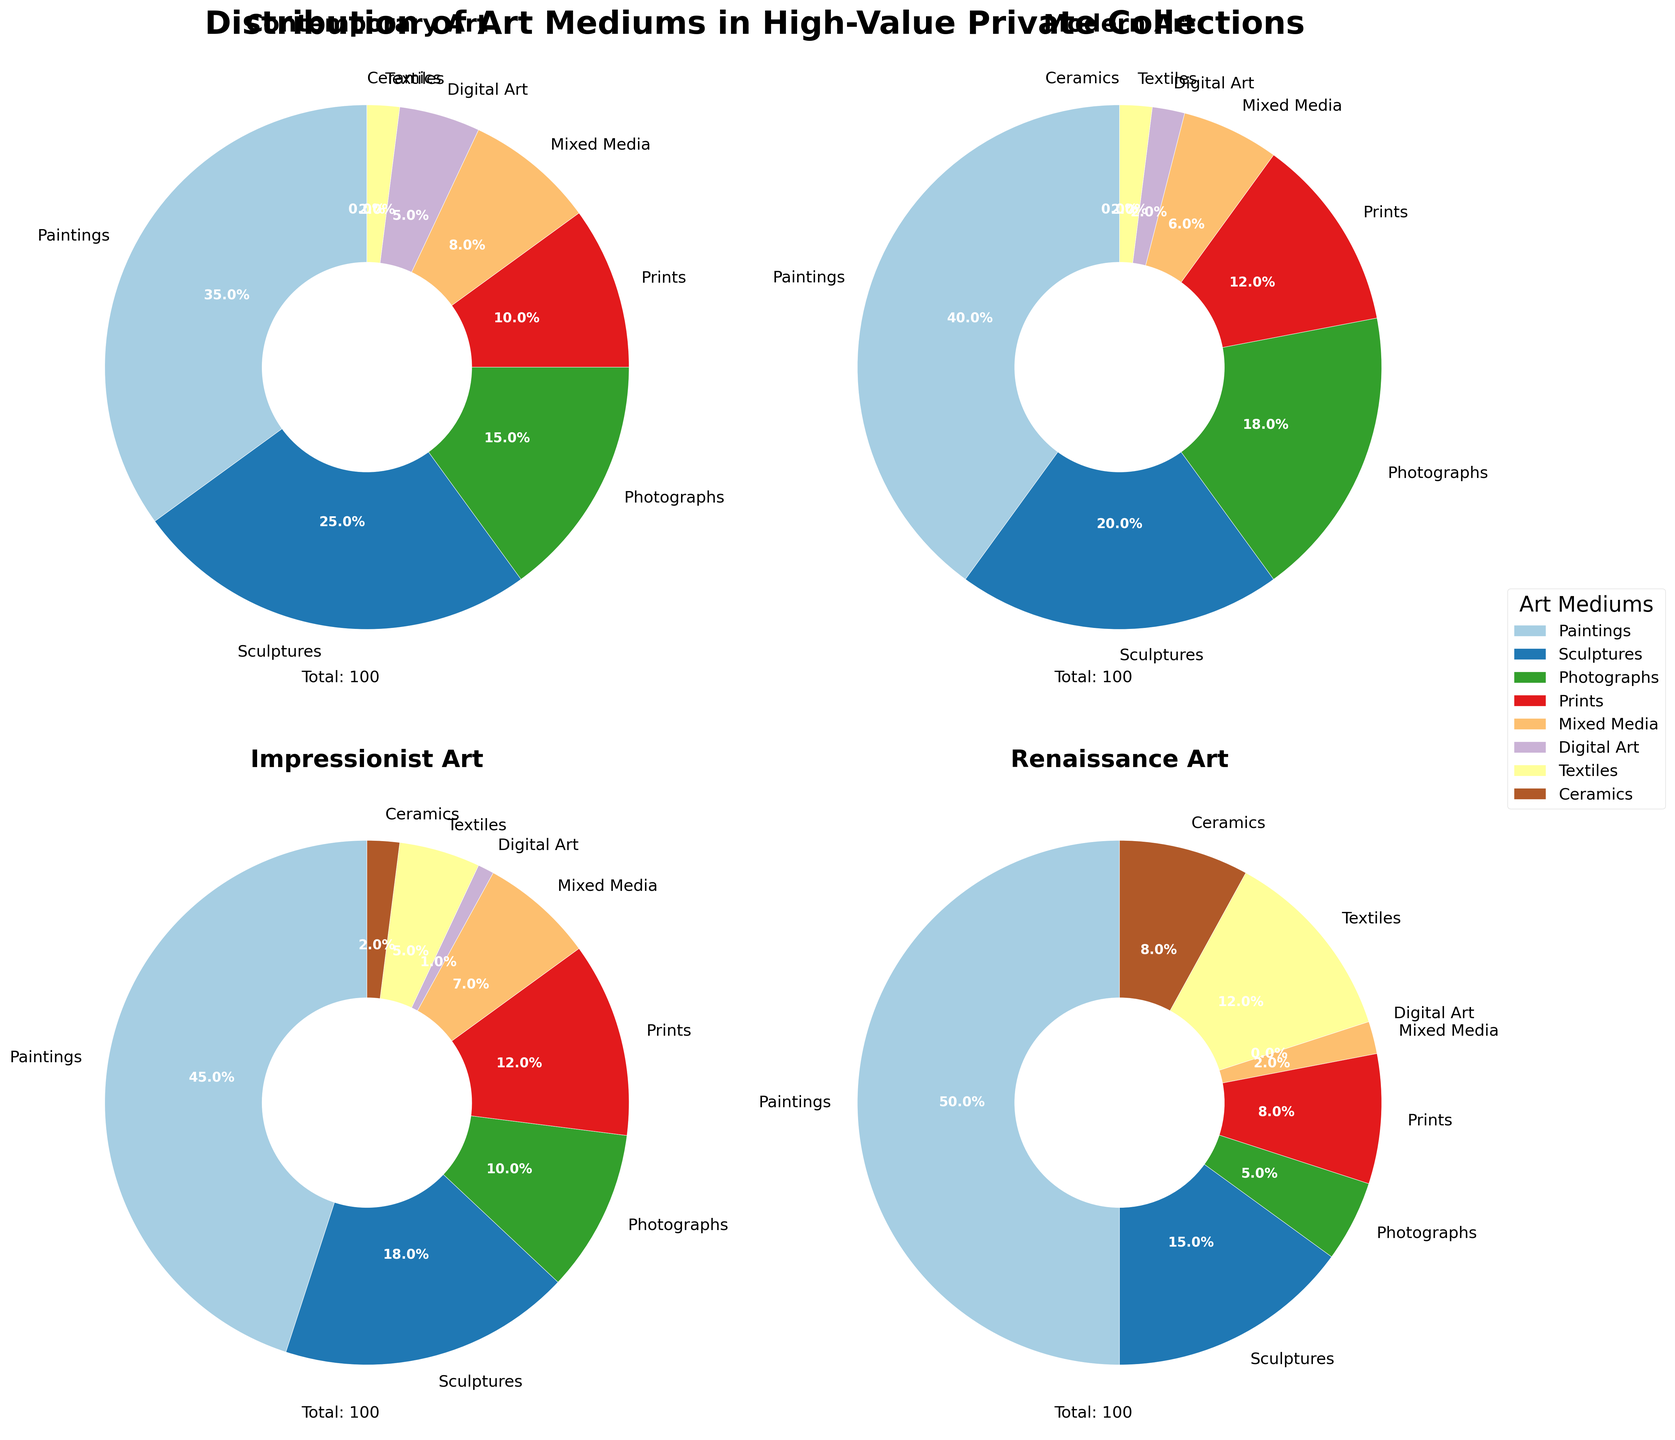Which art period has the highest percentage of paintings? By observing the pie charts, the percentage of paintings is clearly indicated for each art period. Comparing these values across Contemporary, Modern, Impressionist, and Renaissance periods will show which has the highest percentage of paintings.
Answer: Renaissance Which art medium is not present in Contemporary collections but present in other periods? By analyzing the pie chart for the Contemporary period, we notice that Ceramics has a 0% contribution. A quick scan of the other periods' charts will confirm the presence of Ceramics in Modern, Impressionist, or Renaissance collections.
Answer: Ceramics What is the most common art medium in Impressionist collections? The pie chart for the Impressionist period shows a clear division, with the largest segment representing the most common medium. Paintings represent the biggest section in the Impressionist chart.
Answer: Paintings How does the proportion of Photography in Modern collections compare to Impressionist collections? By observing both charts, note the percentage of Photography in the Modern period (18%) and compare it to the percentage in the Impressionist period (10%).
Answer: Modern is higher Which pie chart shows the greatest diversity in art mediums? The chart with the most evenly-distributed segments indicates the greatest diversity. Reviewing each pie graph reveals that the Contemporary chart has more evenly-sized segments.
Answer: Contemporary Calculate the total percentage of digital art and textiles in Renaissance collections. From the Renaissance pie chart, Digital Art has 0%, and Textiles have a proportional segment. Summing these values provides the total percentage: 0% (Digital Art) + 12% (Textiles) = 12%.
Answer: 12% Which art medium shows the least proportion in Modern collections? Reviewing the Modern pie chart, identify the smallest segment. Digital Art, at 2%, is the smallest proportion in Modern collections.
Answer: Digital Art Is the percentage of Mixed Media in Impressionist collections greater or less than that in Modern collections? Check the corresponding segments in the Impressionist (7%) and Modern (6%) charts. Comparatively, 7% (Impressionist) is greater than 6% (Modern).
Answer: Greater What is the sum of percentages for the top three largest art mediums in Renaissance collections? Assess the Renaissance pie chart, selecting the three largest sections (Paintings: 50%, Textiles: 12%, Sculptures: 15%). Sum these values: 50% + 15% + 12% = 77%.
Answer: 77% 